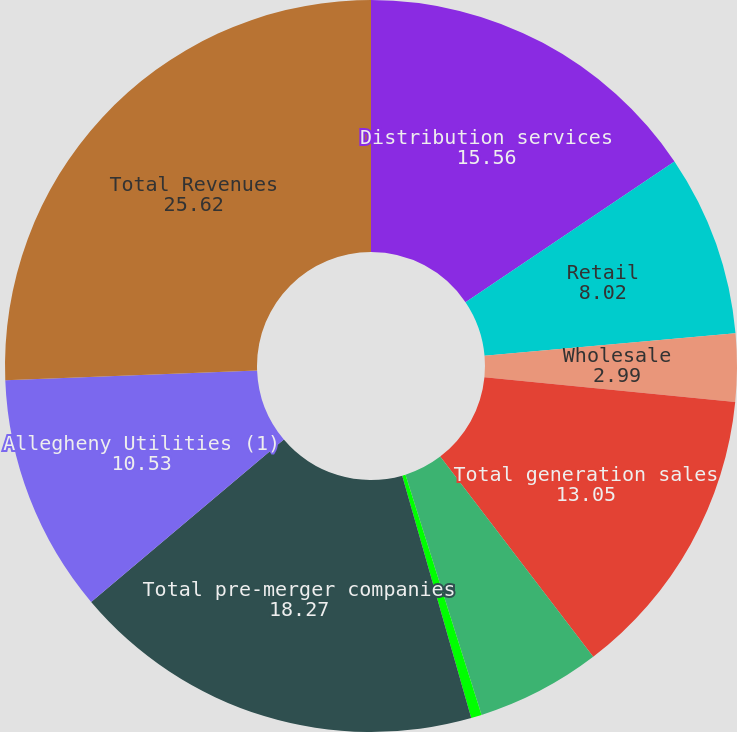<chart> <loc_0><loc_0><loc_500><loc_500><pie_chart><fcel>Distribution services<fcel>Retail<fcel>Wholesale<fcel>Total generation sales<fcel>Transmission<fcel>Other<fcel>Total pre-merger companies<fcel>Allegheny Utilities (1)<fcel>Total Revenues<nl><fcel>15.56%<fcel>8.02%<fcel>2.99%<fcel>13.05%<fcel>5.5%<fcel>0.47%<fcel>18.27%<fcel>10.53%<fcel>25.62%<nl></chart> 